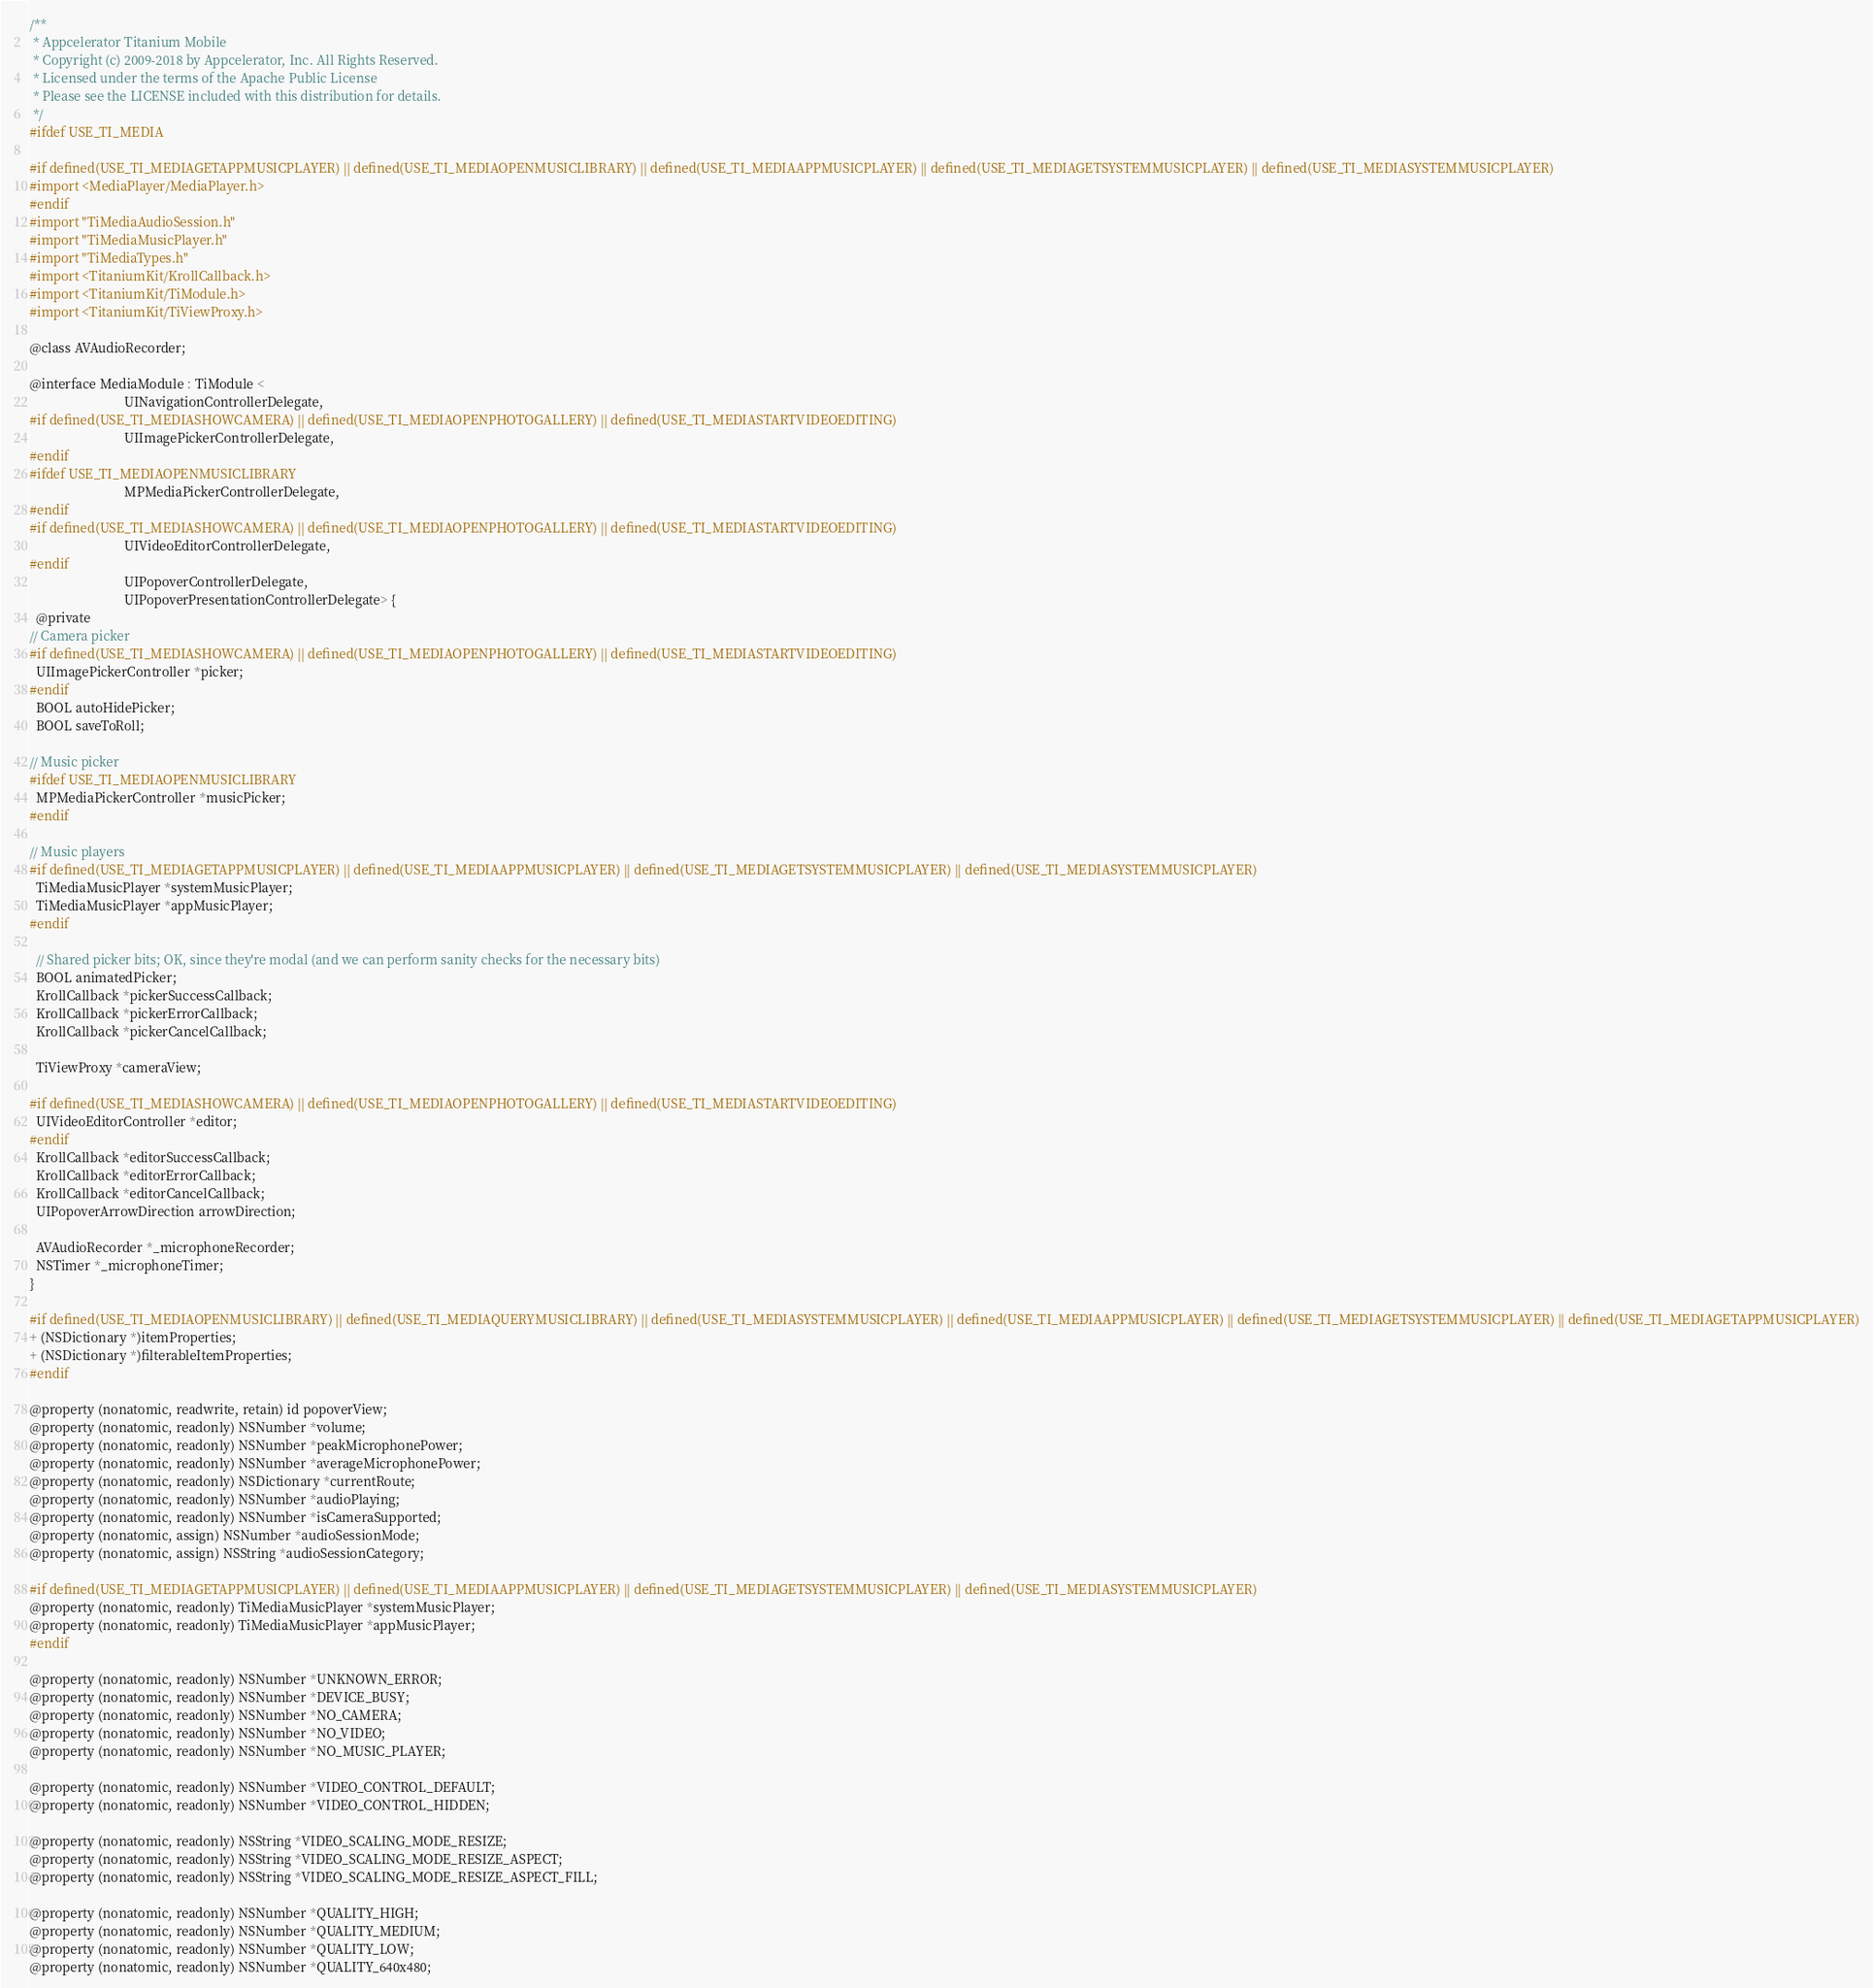Convert code to text. <code><loc_0><loc_0><loc_500><loc_500><_C_>/**
 * Appcelerator Titanium Mobile
 * Copyright (c) 2009-2018 by Appcelerator, Inc. All Rights Reserved.
 * Licensed under the terms of the Apache Public License
 * Please see the LICENSE included with this distribution for details.
 */
#ifdef USE_TI_MEDIA

#if defined(USE_TI_MEDIAGETAPPMUSICPLAYER) || defined(USE_TI_MEDIAOPENMUSICLIBRARY) || defined(USE_TI_MEDIAAPPMUSICPLAYER) || defined(USE_TI_MEDIAGETSYSTEMMUSICPLAYER) || defined(USE_TI_MEDIASYSTEMMUSICPLAYER)
#import <MediaPlayer/MediaPlayer.h>
#endif
#import "TiMediaAudioSession.h"
#import "TiMediaMusicPlayer.h"
#import "TiMediaTypes.h"
#import <TitaniumKit/KrollCallback.h>
#import <TitaniumKit/TiModule.h>
#import <TitaniumKit/TiViewProxy.h>

@class AVAudioRecorder;

@interface MediaModule : TiModule <
                             UINavigationControllerDelegate,
#if defined(USE_TI_MEDIASHOWCAMERA) || defined(USE_TI_MEDIAOPENPHOTOGALLERY) || defined(USE_TI_MEDIASTARTVIDEOEDITING)
                             UIImagePickerControllerDelegate,
#endif
#ifdef USE_TI_MEDIAOPENMUSICLIBRARY
                             MPMediaPickerControllerDelegate,
#endif
#if defined(USE_TI_MEDIASHOWCAMERA) || defined(USE_TI_MEDIAOPENPHOTOGALLERY) || defined(USE_TI_MEDIASTARTVIDEOEDITING)
                             UIVideoEditorControllerDelegate,
#endif
                             UIPopoverControllerDelegate,
                             UIPopoverPresentationControllerDelegate> {
  @private
// Camera picker
#if defined(USE_TI_MEDIASHOWCAMERA) || defined(USE_TI_MEDIAOPENPHOTOGALLERY) || defined(USE_TI_MEDIASTARTVIDEOEDITING)
  UIImagePickerController *picker;
#endif
  BOOL autoHidePicker;
  BOOL saveToRoll;

// Music picker
#ifdef USE_TI_MEDIAOPENMUSICLIBRARY
  MPMediaPickerController *musicPicker;
#endif

// Music players
#if defined(USE_TI_MEDIAGETAPPMUSICPLAYER) || defined(USE_TI_MEDIAAPPMUSICPLAYER) || defined(USE_TI_MEDIAGETSYSTEMMUSICPLAYER) || defined(USE_TI_MEDIASYSTEMMUSICPLAYER)
  TiMediaMusicPlayer *systemMusicPlayer;
  TiMediaMusicPlayer *appMusicPlayer;
#endif

  // Shared picker bits; OK, since they're modal (and we can perform sanity checks for the necessary bits)
  BOOL animatedPicker;
  KrollCallback *pickerSuccessCallback;
  KrollCallback *pickerErrorCallback;
  KrollCallback *pickerCancelCallback;

  TiViewProxy *cameraView;

#if defined(USE_TI_MEDIASHOWCAMERA) || defined(USE_TI_MEDIAOPENPHOTOGALLERY) || defined(USE_TI_MEDIASTARTVIDEOEDITING)
  UIVideoEditorController *editor;
#endif
  KrollCallback *editorSuccessCallback;
  KrollCallback *editorErrorCallback;
  KrollCallback *editorCancelCallback;
  UIPopoverArrowDirection arrowDirection;

  AVAudioRecorder *_microphoneRecorder;
  NSTimer *_microphoneTimer;
}

#if defined(USE_TI_MEDIAOPENMUSICLIBRARY) || defined(USE_TI_MEDIAQUERYMUSICLIBRARY) || defined(USE_TI_MEDIASYSTEMMUSICPLAYER) || defined(USE_TI_MEDIAAPPMUSICPLAYER) || defined(USE_TI_MEDIAGETSYSTEMMUSICPLAYER) || defined(USE_TI_MEDIAGETAPPMUSICPLAYER)
+ (NSDictionary *)itemProperties;
+ (NSDictionary *)filterableItemProperties;
#endif

@property (nonatomic, readwrite, retain) id popoverView;
@property (nonatomic, readonly) NSNumber *volume;
@property (nonatomic, readonly) NSNumber *peakMicrophonePower;
@property (nonatomic, readonly) NSNumber *averageMicrophonePower;
@property (nonatomic, readonly) NSDictionary *currentRoute;
@property (nonatomic, readonly) NSNumber *audioPlaying;
@property (nonatomic, readonly) NSNumber *isCameraSupported;
@property (nonatomic, assign) NSNumber *audioSessionMode;
@property (nonatomic, assign) NSString *audioSessionCategory;

#if defined(USE_TI_MEDIAGETAPPMUSICPLAYER) || defined(USE_TI_MEDIAAPPMUSICPLAYER) || defined(USE_TI_MEDIAGETSYSTEMMUSICPLAYER) || defined(USE_TI_MEDIASYSTEMMUSICPLAYER)
@property (nonatomic, readonly) TiMediaMusicPlayer *systemMusicPlayer;
@property (nonatomic, readonly) TiMediaMusicPlayer *appMusicPlayer;
#endif

@property (nonatomic, readonly) NSNumber *UNKNOWN_ERROR;
@property (nonatomic, readonly) NSNumber *DEVICE_BUSY;
@property (nonatomic, readonly) NSNumber *NO_CAMERA;
@property (nonatomic, readonly) NSNumber *NO_VIDEO;
@property (nonatomic, readonly) NSNumber *NO_MUSIC_PLAYER;

@property (nonatomic, readonly) NSNumber *VIDEO_CONTROL_DEFAULT;
@property (nonatomic, readonly) NSNumber *VIDEO_CONTROL_HIDDEN;

@property (nonatomic, readonly) NSString *VIDEO_SCALING_MODE_RESIZE;
@property (nonatomic, readonly) NSString *VIDEO_SCALING_MODE_RESIZE_ASPECT;
@property (nonatomic, readonly) NSString *VIDEO_SCALING_MODE_RESIZE_ASPECT_FILL;

@property (nonatomic, readonly) NSNumber *QUALITY_HIGH;
@property (nonatomic, readonly) NSNumber *QUALITY_MEDIUM;
@property (nonatomic, readonly) NSNumber *QUALITY_LOW;
@property (nonatomic, readonly) NSNumber *QUALITY_640x480;</code> 